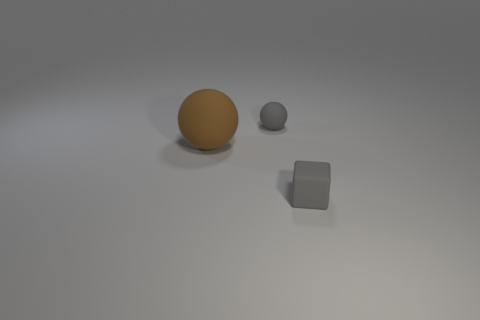Add 3 blocks. How many objects exist? 6 Subtract 1 gray spheres. How many objects are left? 2 Subtract all blocks. How many objects are left? 2 Subtract all tiny gray matte spheres. Subtract all tiny matte objects. How many objects are left? 0 Add 3 gray things. How many gray things are left? 5 Add 2 brown metallic cubes. How many brown metallic cubes exist? 2 